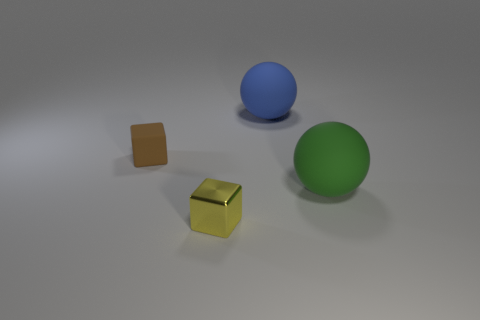Subtract all brown blocks. How many blocks are left? 1 Subtract 2 cubes. How many cubes are left? 0 Add 1 blue matte spheres. How many objects exist? 5 Add 3 yellow shiny things. How many yellow shiny things are left? 4 Add 4 small cyan spheres. How many small cyan spheres exist? 4 Subtract 0 yellow spheres. How many objects are left? 4 Subtract all blue cubes. Subtract all red balls. How many cubes are left? 2 Subtract all tiny red metallic cubes. Subtract all tiny objects. How many objects are left? 2 